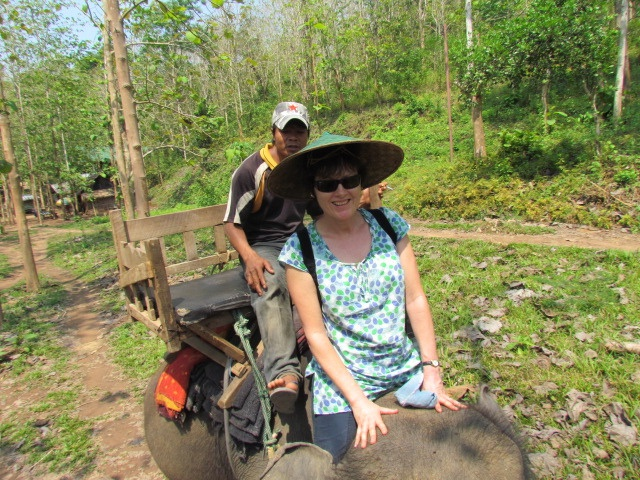Describe the objects in this image and their specific colors. I can see people in tan, black, white, and gray tones, elephant in tan, gray, and black tones, bench in tan, gray, and black tones, people in tan, black, gray, and darkgray tones, and backpack in tan, black, gray, darkgray, and purple tones in this image. 